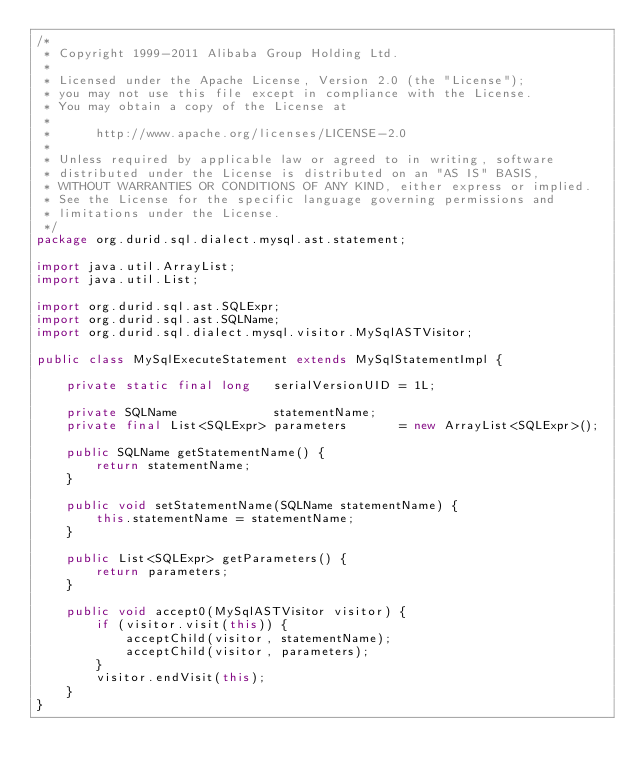Convert code to text. <code><loc_0><loc_0><loc_500><loc_500><_Java_>/*
 * Copyright 1999-2011 Alibaba Group Holding Ltd.
 *
 * Licensed under the Apache License, Version 2.0 (the "License");
 * you may not use this file except in compliance with the License.
 * You may obtain a copy of the License at
 *
 *      http://www.apache.org/licenses/LICENSE-2.0
 *
 * Unless required by applicable law or agreed to in writing, software
 * distributed under the License is distributed on an "AS IS" BASIS,
 * WITHOUT WARRANTIES OR CONDITIONS OF ANY KIND, either express or implied.
 * See the License for the specific language governing permissions and
 * limitations under the License.
 */
package org.durid.sql.dialect.mysql.ast.statement;

import java.util.ArrayList;
import java.util.List;

import org.durid.sql.ast.SQLExpr;
import org.durid.sql.ast.SQLName;
import org.durid.sql.dialect.mysql.visitor.MySqlASTVisitor;

public class MySqlExecuteStatement extends MySqlStatementImpl {

    private static final long   serialVersionUID = 1L;

    private SQLName             statementName;
    private final List<SQLExpr> parameters       = new ArrayList<SQLExpr>();

    public SQLName getStatementName() {
        return statementName;
    }

    public void setStatementName(SQLName statementName) {
        this.statementName = statementName;
    }

    public List<SQLExpr> getParameters() {
        return parameters;
    }

    public void accept0(MySqlASTVisitor visitor) {
        if (visitor.visit(this)) {
            acceptChild(visitor, statementName);
            acceptChild(visitor, parameters);
        }
        visitor.endVisit(this);
    }
}
</code> 